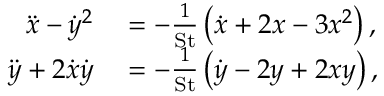Convert formula to latex. <formula><loc_0><loc_0><loc_500><loc_500>\begin{array} { r l } { \ddot { x } - \dot { y } ^ { 2 } } & = - \frac { 1 } { S t } \left ( \dot { x } + 2 x - 3 x ^ { 2 } \right ) , } \\ { \ddot { y } + 2 \dot { x } \dot { y } } & = - \frac { 1 } { S t } \left ( \dot { y } - 2 y + 2 x y \right ) , } \end{array}</formula> 